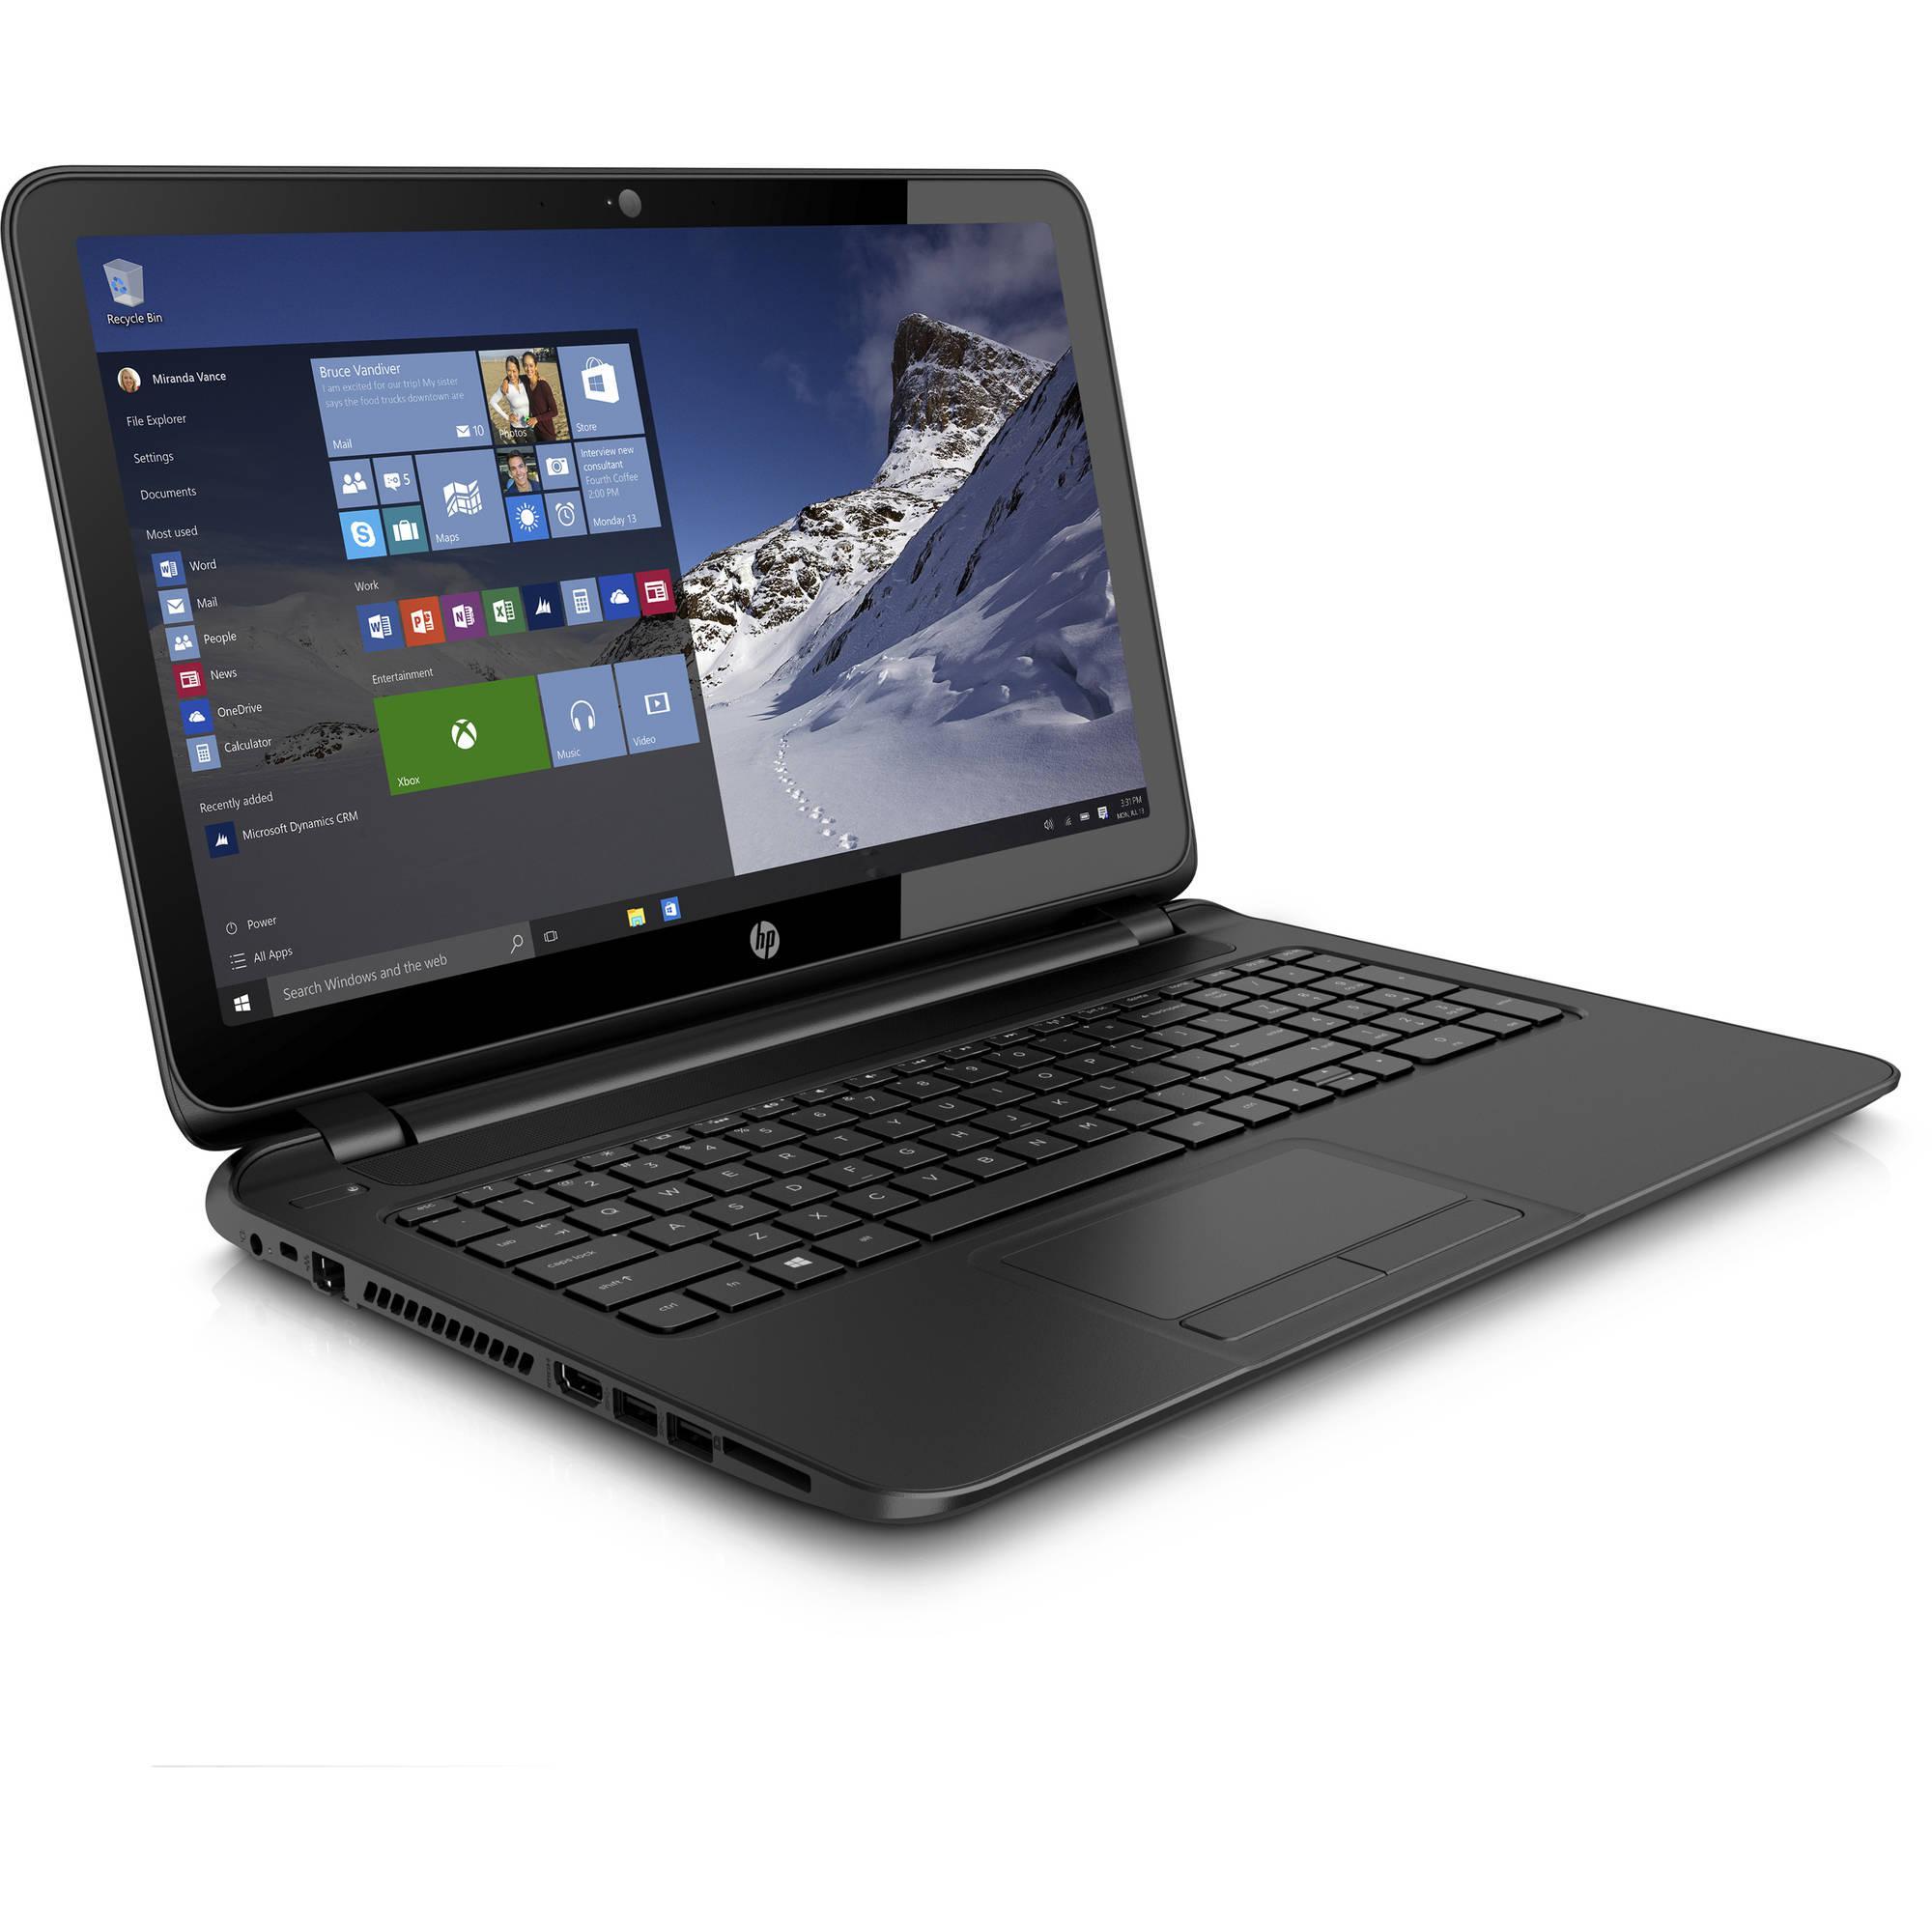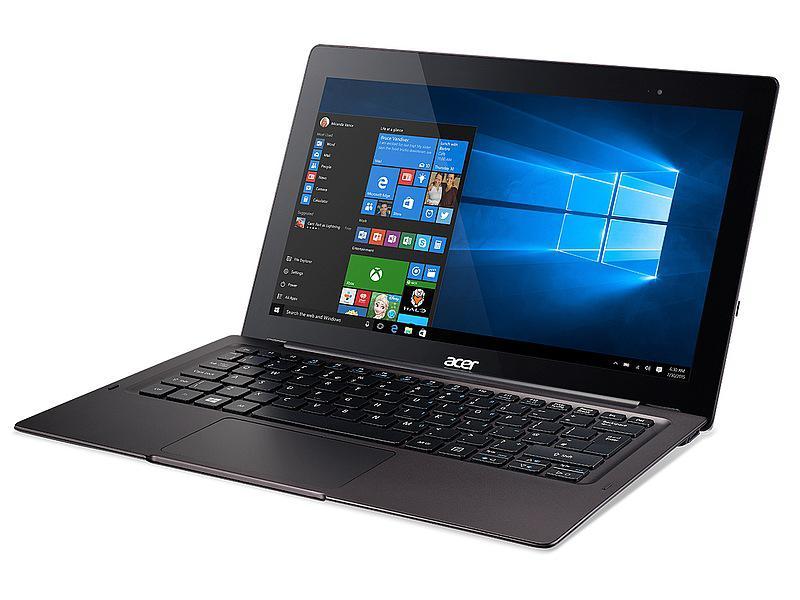The first image is the image on the left, the second image is the image on the right. For the images shown, is this caption "The laptop on the right is displayed head-on, opened at a right angle, with its screen showing blue and white circle logo." true? Answer yes or no. No. The first image is the image on the left, the second image is the image on the right. Given the left and right images, does the statement "One laptop screen shows the HP logo and the other shows a windows desktop with a picture of a snowy mountain." hold true? Answer yes or no. No. 